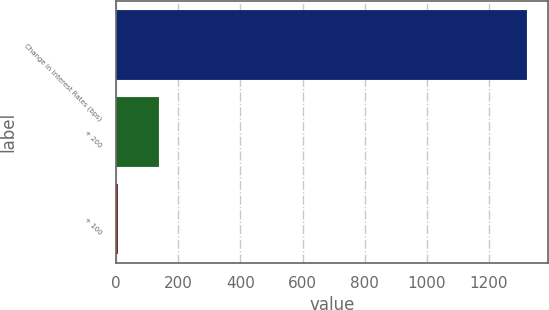Convert chart. <chart><loc_0><loc_0><loc_500><loc_500><bar_chart><fcel>Change in Interest Rates (bps)<fcel>+ 200<fcel>+ 100<nl><fcel>1324<fcel>136.13<fcel>4.14<nl></chart> 